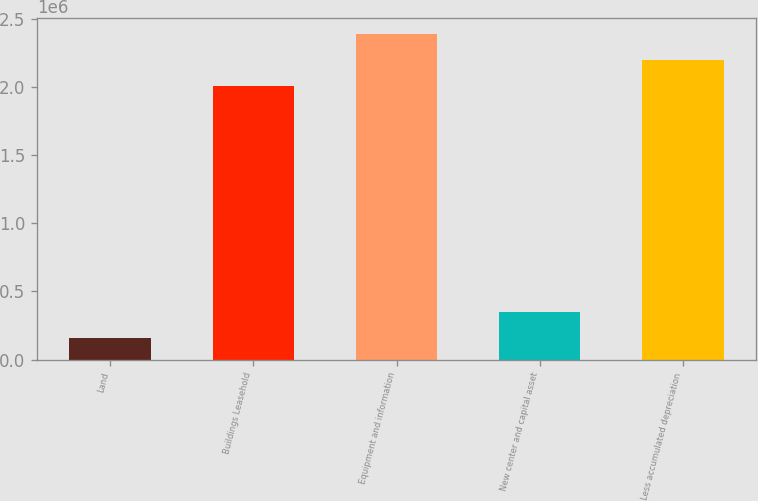Convert chart. <chart><loc_0><loc_0><loc_500><loc_500><bar_chart><fcel>Land<fcel>Buildings Leasehold<fcel>Equipment and information<fcel>New center and capital asset<fcel>Less accumulated depreciation<nl><fcel>157550<fcel>2.00274e+06<fcel>2.38458e+06<fcel>348472<fcel>2.19366e+06<nl></chart> 